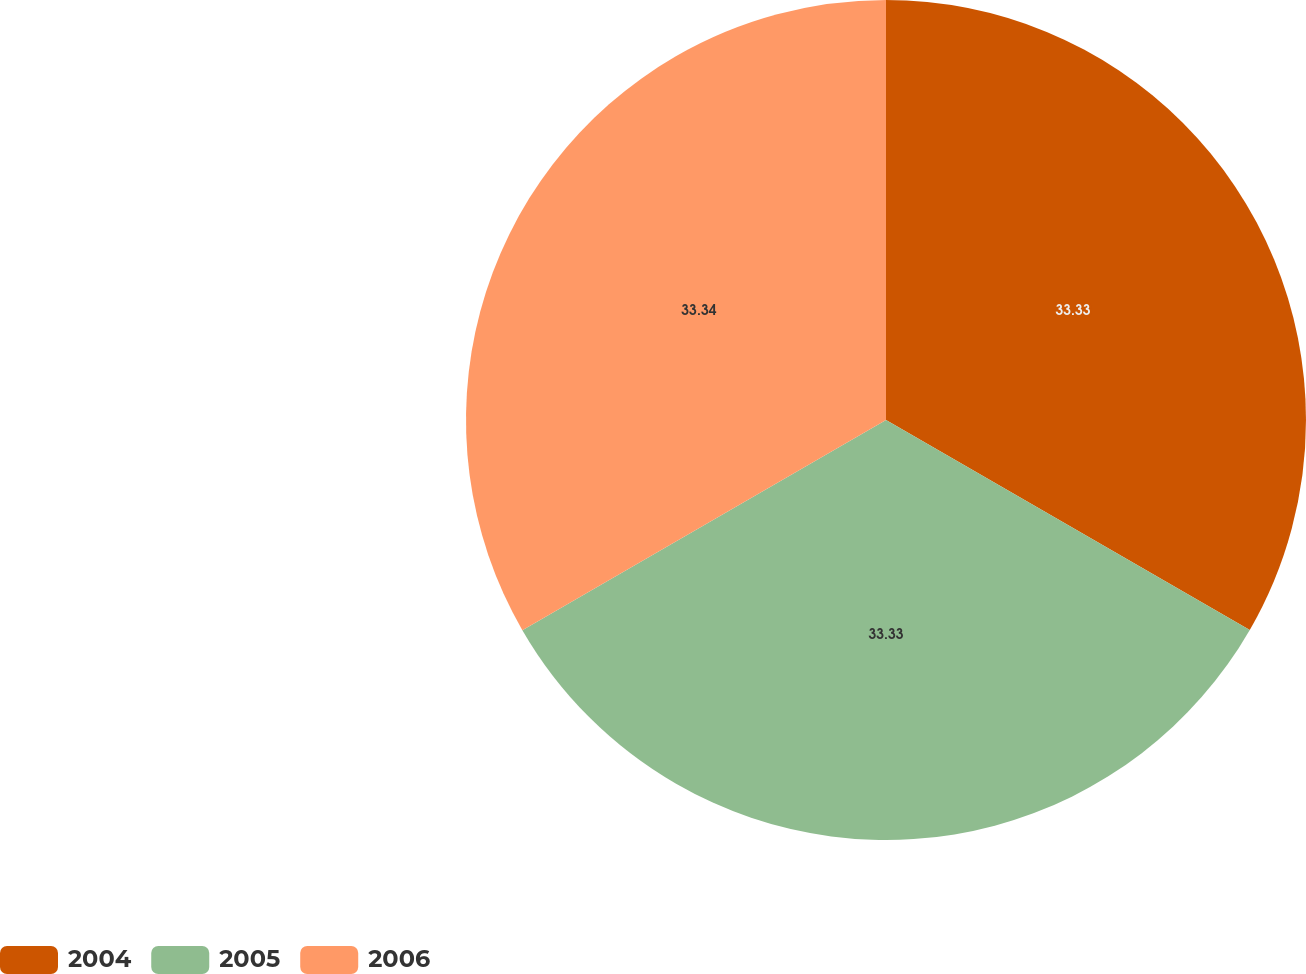Convert chart to OTSL. <chart><loc_0><loc_0><loc_500><loc_500><pie_chart><fcel>2004<fcel>2005<fcel>2006<nl><fcel>33.33%<fcel>33.33%<fcel>33.34%<nl></chart> 